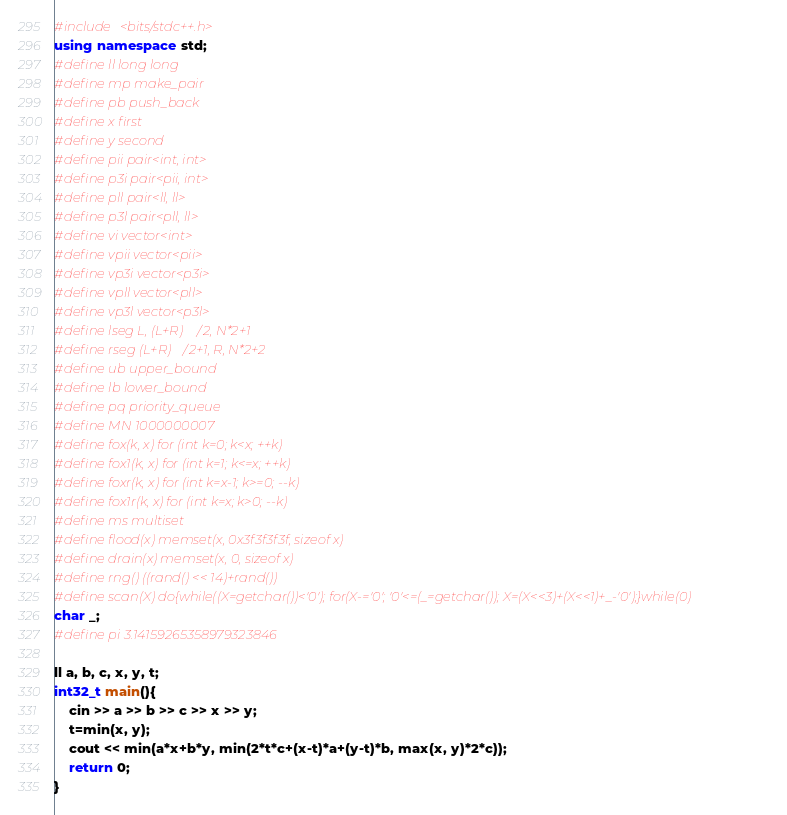<code> <loc_0><loc_0><loc_500><loc_500><_C++_>#include <bits/stdc++.h>
using namespace std;
#define ll long long
#define mp make_pair
#define pb push_back
#define x first
#define y second
#define pii pair<int, int>
#define p3i pair<pii, int>
#define pll pair<ll, ll>
#define p3l pair<pll, ll>
#define vi vector<int>
#define vpii vector<pii>
#define vp3i vector<p3i>
#define vpll vector<pll>
#define vp3l vector<p3l>
#define lseg L, (L+R)/2, N*2+1
#define rseg (L+R)/2+1, R, N*2+2
#define ub upper_bound
#define lb lower_bound
#define pq priority_queue
#define MN 1000000007
#define fox(k, x) for (int k=0; k<x; ++k)
#define fox1(k, x) for (int k=1; k<=x; ++k)
#define foxr(k, x) for (int k=x-1; k>=0; --k)
#define fox1r(k, x) for (int k=x; k>0; --k)
#define ms multiset
#define flood(x) memset(x, 0x3f3f3f3f, sizeof x)
#define drain(x) memset(x, 0, sizeof x)
#define rng() ((rand() << 14)+rand())
#define scan(X) do{while((X=getchar())<'0'); for(X-='0'; '0'<=(_=getchar()); X=(X<<3)+(X<<1)+_-'0');}while(0)
char _;
#define pi 3.14159265358979323846

ll a, b, c, x, y, t;
int32_t main(){
    cin >> a >> b >> c >> x >> y;
    t=min(x, y);
    cout << min(a*x+b*y, min(2*t*c+(x-t)*a+(y-t)*b, max(x, y)*2*c));
    return 0;
}
</code> 